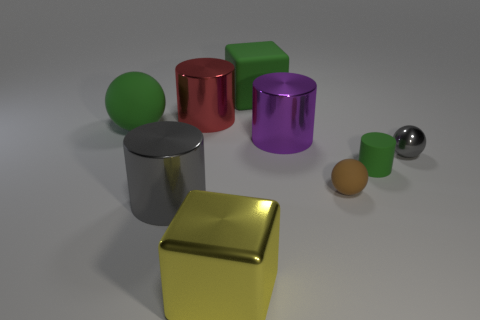How big is the gray shiny thing that is right of the green object that is to the right of the large block that is behind the brown sphere?
Offer a very short reply. Small. What number of objects are big green objects that are behind the green sphere or yellow metallic cylinders?
Provide a succinct answer. 1. There is a gray shiny thing that is to the right of the purple cylinder; how many gray things are in front of it?
Your response must be concise. 1. Is the number of metal blocks left of the small cylinder greater than the number of big gray metallic spheres?
Offer a very short reply. Yes. What is the size of the cylinder that is in front of the tiny metallic thing and to the right of the big red metallic object?
Offer a very short reply. Small. What shape is the green matte object that is both behind the small gray sphere and right of the large rubber sphere?
Make the answer very short. Cube. There is a large green object behind the sphere left of the green block; is there a large gray object that is behind it?
Offer a terse response. No. How many things are either gray things to the left of the purple shiny object or large things that are behind the gray metallic sphere?
Offer a terse response. 5. Do the tiny thing on the right side of the small green object and the large green sphere have the same material?
Make the answer very short. No. The cylinder that is both behind the tiny rubber cylinder and in front of the red cylinder is made of what material?
Provide a short and direct response. Metal. 